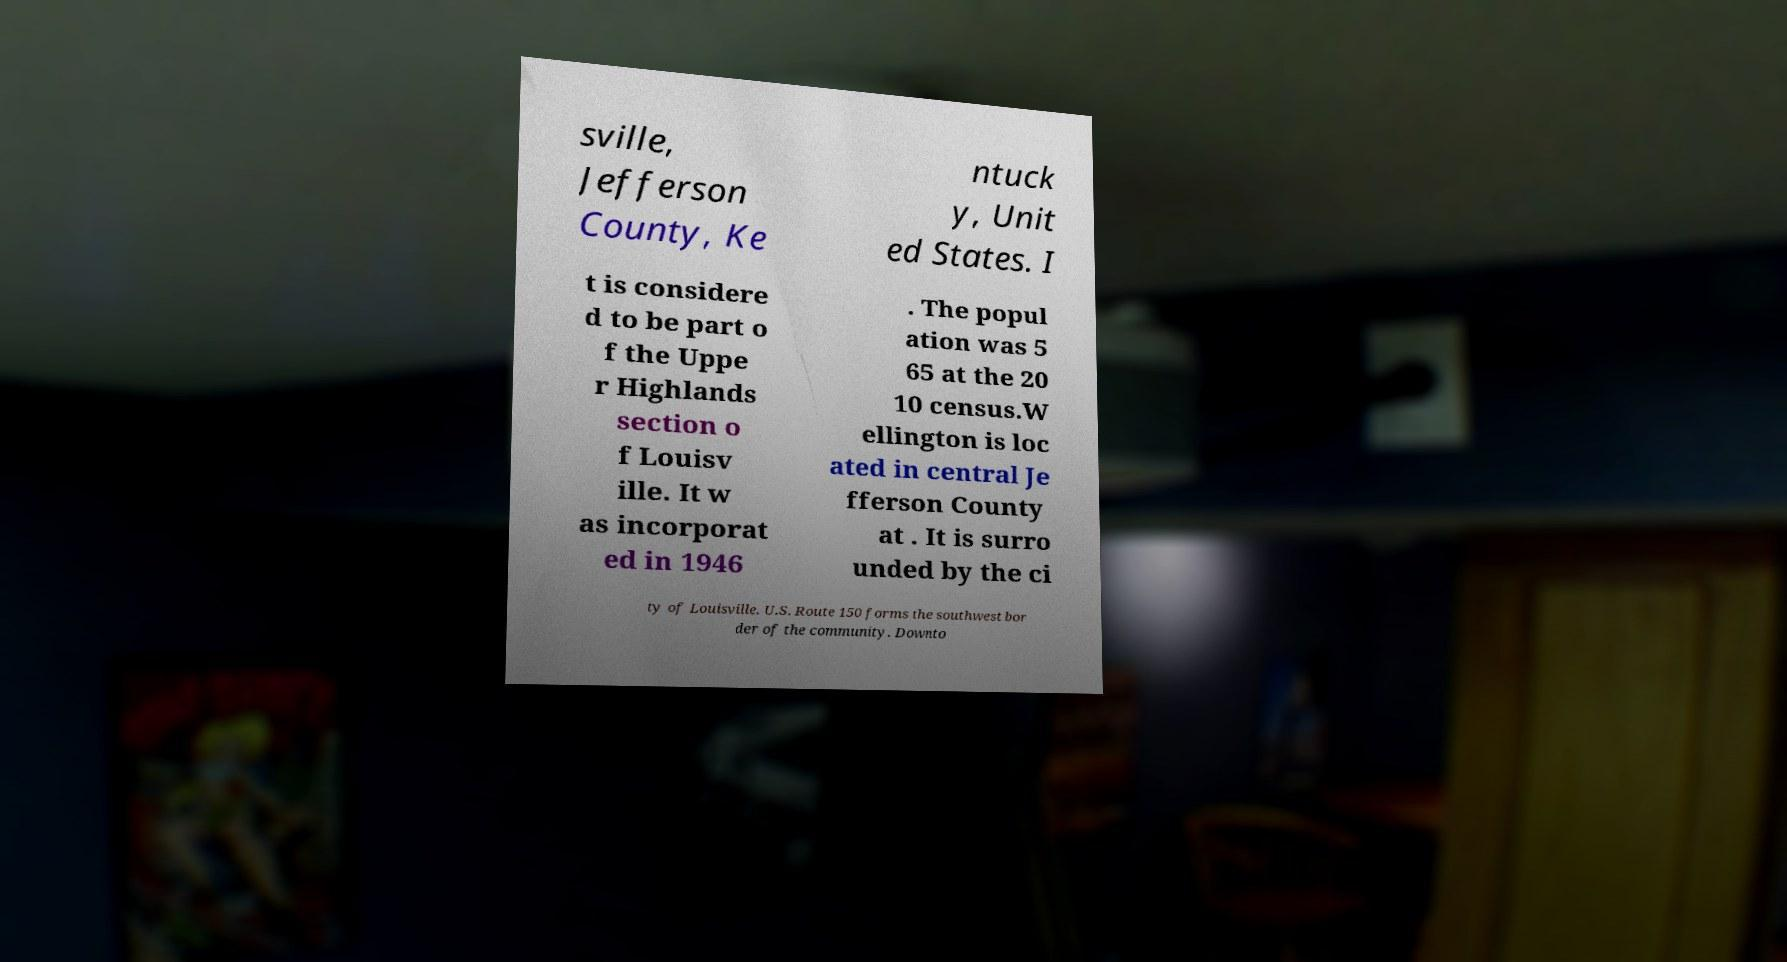I need the written content from this picture converted into text. Can you do that? sville, Jefferson County, Ke ntuck y, Unit ed States. I t is considere d to be part o f the Uppe r Highlands section o f Louisv ille. It w as incorporat ed in 1946 . The popul ation was 5 65 at the 20 10 census.W ellington is loc ated in central Je fferson County at . It is surro unded by the ci ty of Louisville. U.S. Route 150 forms the southwest bor der of the community. Downto 